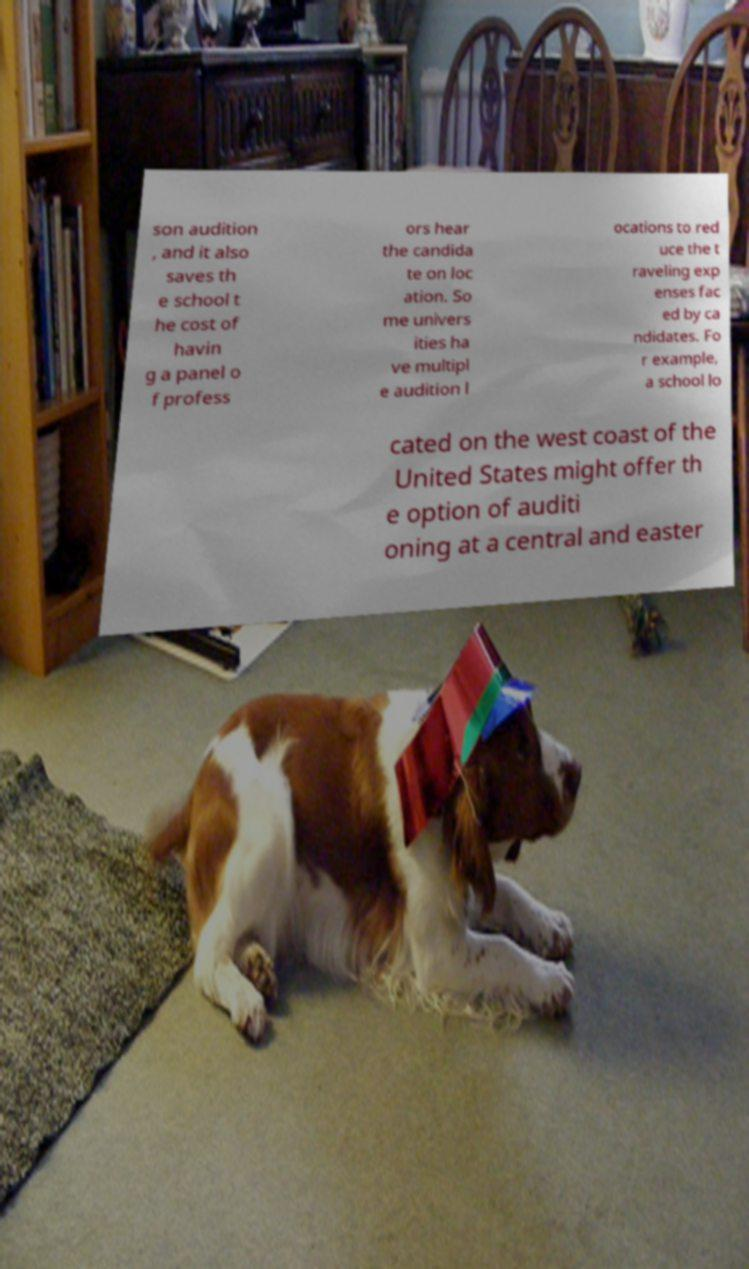Please read and relay the text visible in this image. What does it say? son audition , and it also saves th e school t he cost of havin g a panel o f profess ors hear the candida te on loc ation. So me univers ities ha ve multipl e audition l ocations to red uce the t raveling exp enses fac ed by ca ndidates. Fo r example, a school lo cated on the west coast of the United States might offer th e option of auditi oning at a central and easter 